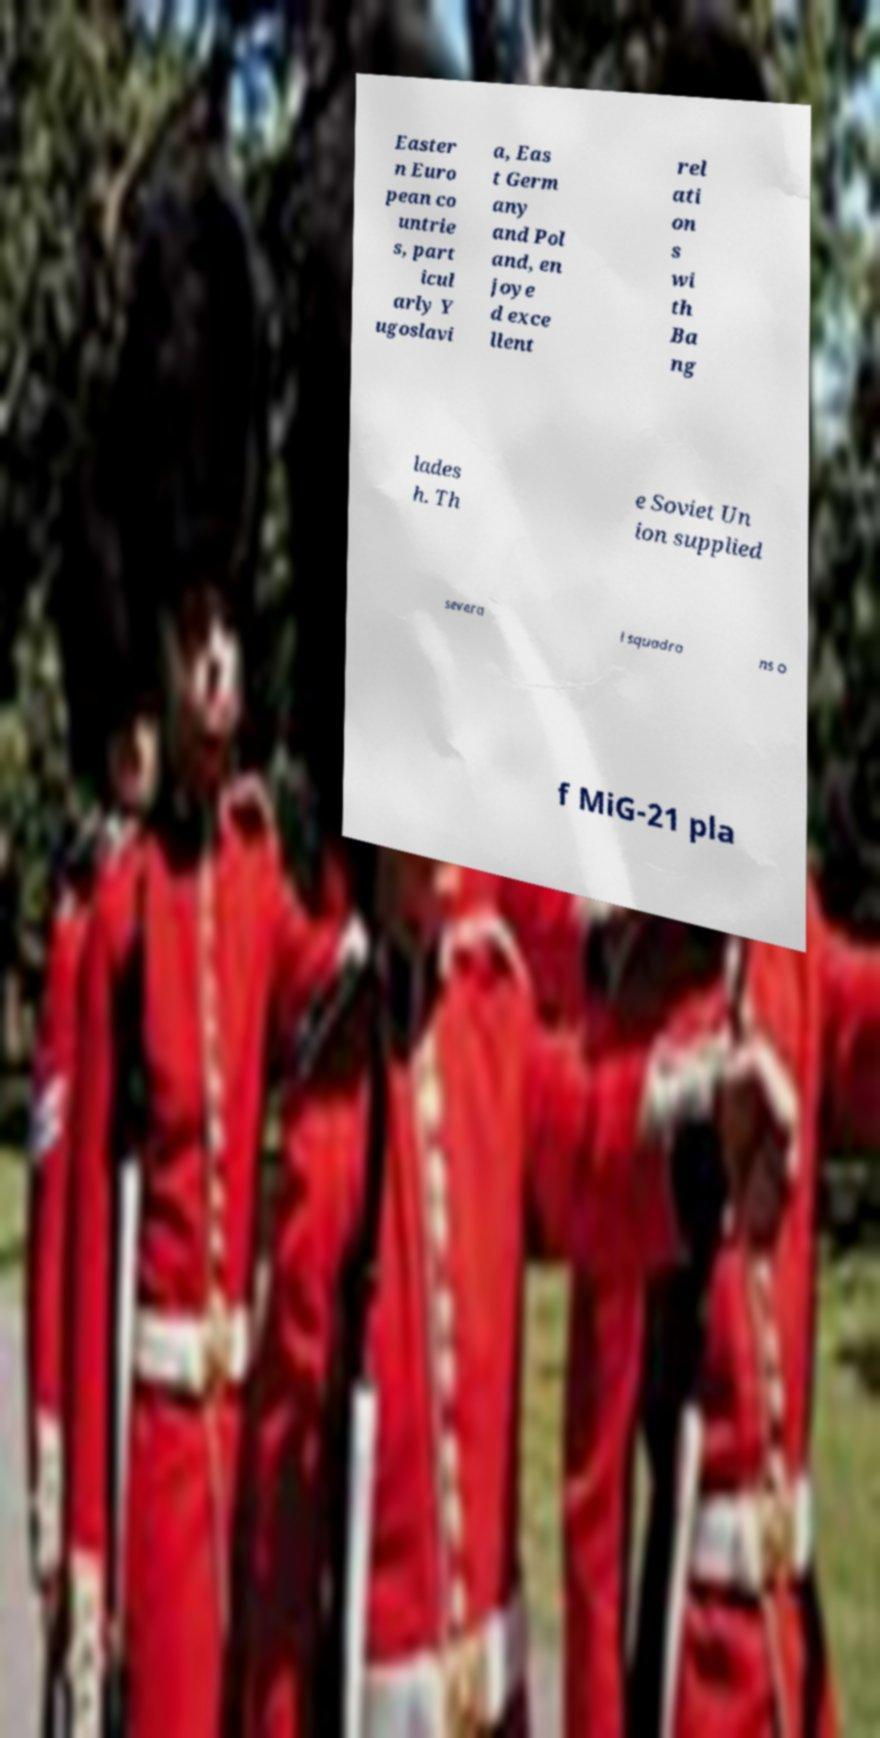Please identify and transcribe the text found in this image. Easter n Euro pean co untrie s, part icul arly Y ugoslavi a, Eas t Germ any and Pol and, en joye d exce llent rel ati on s wi th Ba ng lades h. Th e Soviet Un ion supplied severa l squadro ns o f MiG-21 pla 